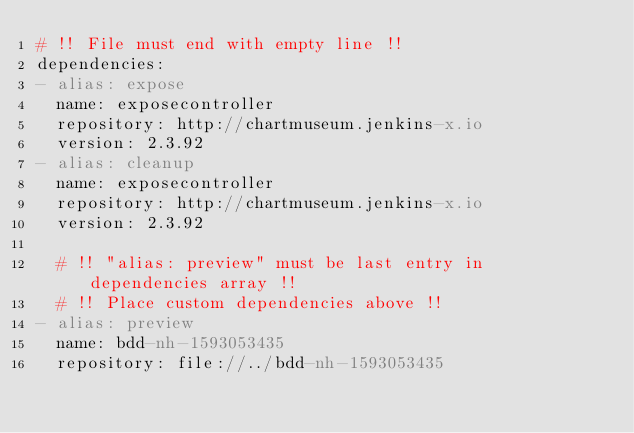Convert code to text. <code><loc_0><loc_0><loc_500><loc_500><_YAML_># !! File must end with empty line !!
dependencies:
- alias: expose
  name: exposecontroller
  repository: http://chartmuseum.jenkins-x.io
  version: 2.3.92
- alias: cleanup
  name: exposecontroller
  repository: http://chartmuseum.jenkins-x.io
  version: 2.3.92

  # !! "alias: preview" must be last entry in dependencies array !!
  # !! Place custom dependencies above !!
- alias: preview
  name: bdd-nh-1593053435
  repository: file://../bdd-nh-1593053435
</code> 